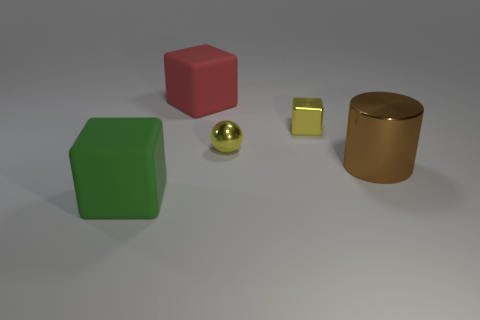Add 2 large green objects. How many objects exist? 7 Subtract all cubes. How many objects are left? 2 Add 4 green matte cubes. How many green matte cubes exist? 5 Subtract 0 red balls. How many objects are left? 5 Subtract all blue metallic cubes. Subtract all green things. How many objects are left? 4 Add 4 shiny cylinders. How many shiny cylinders are left? 5 